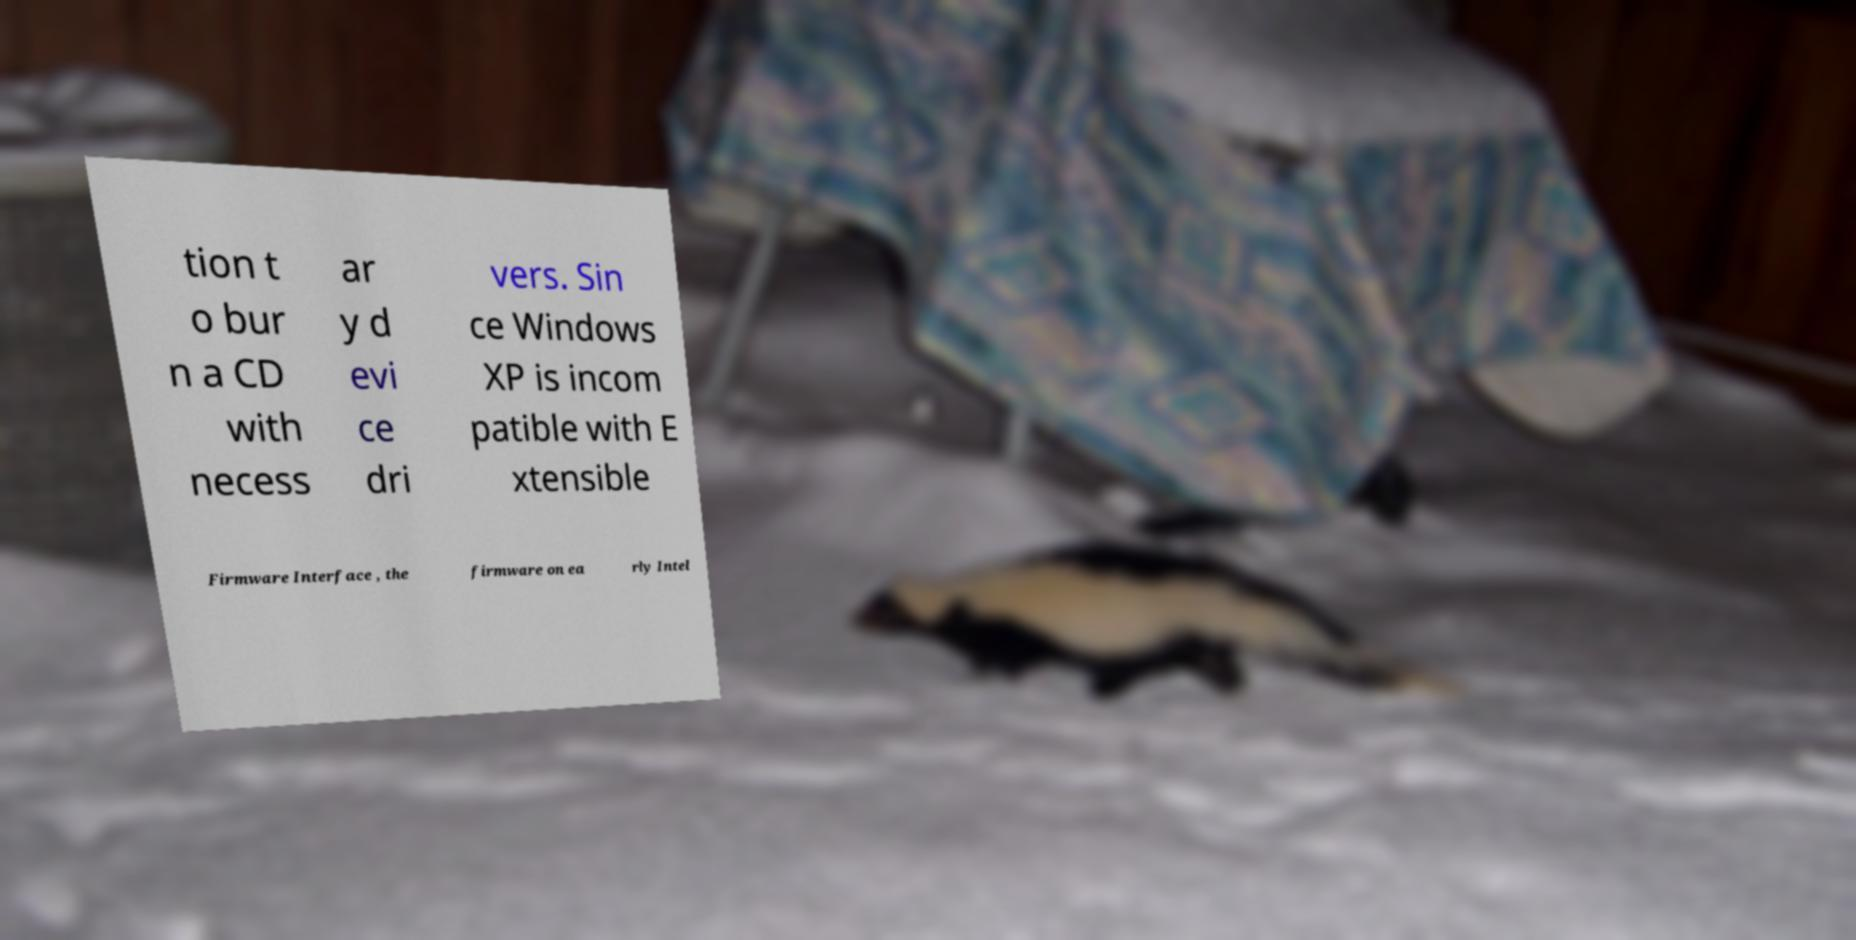There's text embedded in this image that I need extracted. Can you transcribe it verbatim? tion t o bur n a CD with necess ar y d evi ce dri vers. Sin ce Windows XP is incom patible with E xtensible Firmware Interface , the firmware on ea rly Intel 